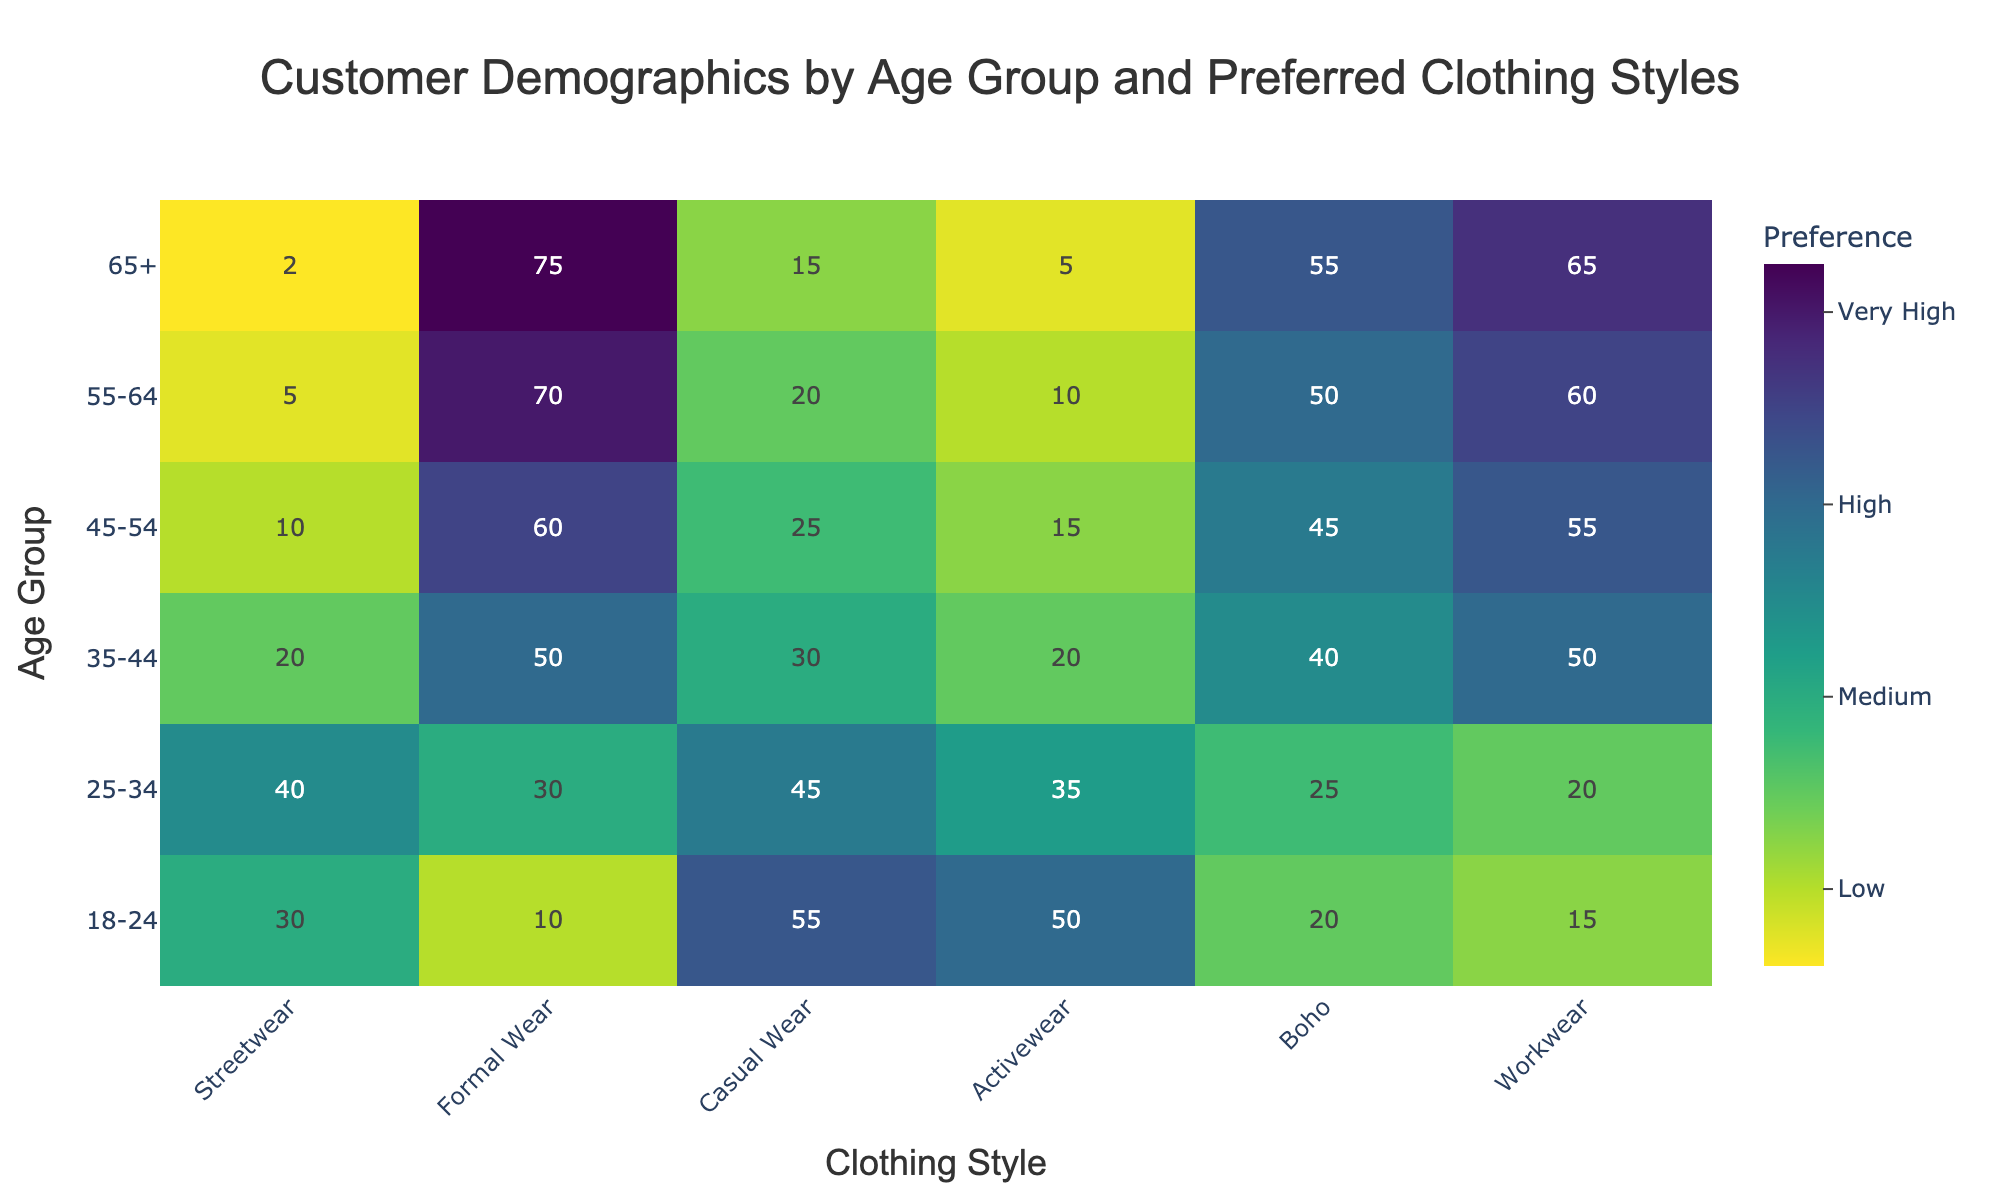What is the most preferred clothing style for the age group 18-24? The value for "Casual Wear" in the age group 18-24 is 55, which is the highest among the clothing styles for that group.
Answer: Casual Wear How do preferences for Streetwear change across age groups? Preferences for Streetwear decrease steadily as age increases, starting from 30 for 18-24 down to 2 for 65+.
Answer: Decrease What is the least preferred clothing style for the age group 45-54? The value for "Activewear" in the age group 45-54 is 15, which is the lowest among the clothing styles for that group.
Answer: Activewear Which age group has the highest preference for Workwear? The value for "Workwear" for the age group 65+ is 65, which is the highest preference among all age groups.
Answer: 65+ Which age group shows the highest interest in Formal Wear? The value for "Formal Wear" for the age group 65+ is 75, which is the highest among all age groups.
Answer: 65+ Compare the preference for Boho between age group 25-34 and 55-64. The value for "Boho" is 25 for age group 25-34 and 50 for age group 55-64. Therefore, 55-64 prefers Boho more than 25-34 by 25 units.
Answer: 55-64 prefers more What's the total preference for Casual Wear across all age groups? The preferences for Casual Wear across all age groups: 55 + 45 + 30 + 25 + 20 + 15 = 190.
Answer: 190 Between Activewear and Streetwear, which clothing style has a higher preference for the age group 35-44? The value for "Activewear" for the age group 35-44 is 20, and for "Streetwear" it is also 20. Both have equal preference.
Answer: Equal preference What is the average preference for Formal Wear across all age groups? The values for Formal Wear are 10, 30, 50, 60, 70, and 75. The average is calculated as (10 + 30 + 50 + 60 + 70 + 75) / 6 = 295 / 6 ≈ 49.17.
Answer: 49.17 